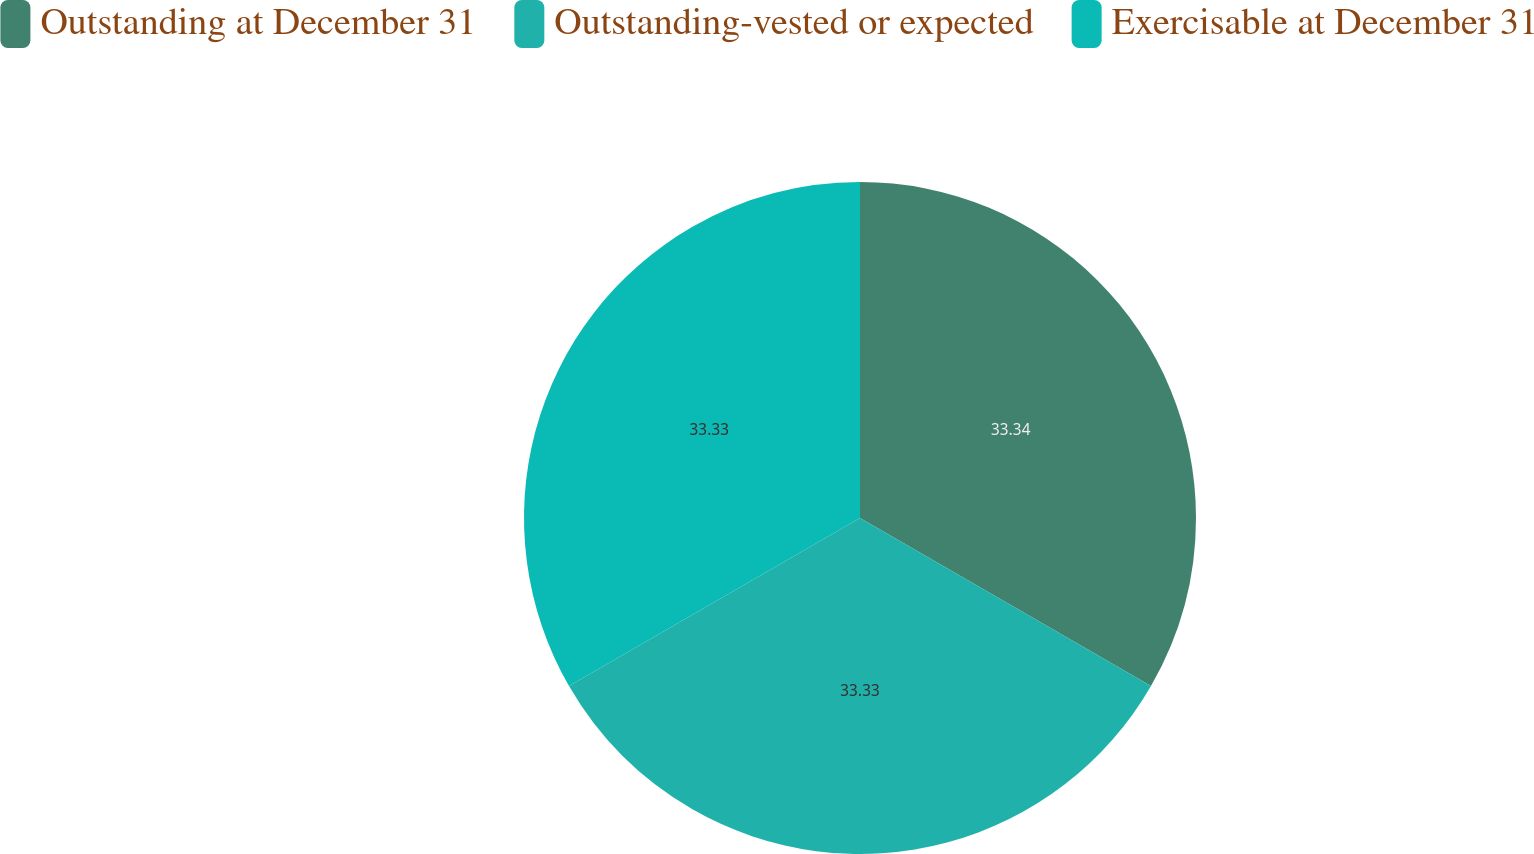<chart> <loc_0><loc_0><loc_500><loc_500><pie_chart><fcel>Outstanding at December 31<fcel>Outstanding-vested or expected<fcel>Exercisable at December 31<nl><fcel>33.33%<fcel>33.33%<fcel>33.33%<nl></chart> 